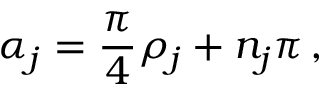<formula> <loc_0><loc_0><loc_500><loc_500>\alpha _ { j } = \frac { \pi } { 4 } \rho _ { j } + n _ { j } \pi \, ,</formula> 